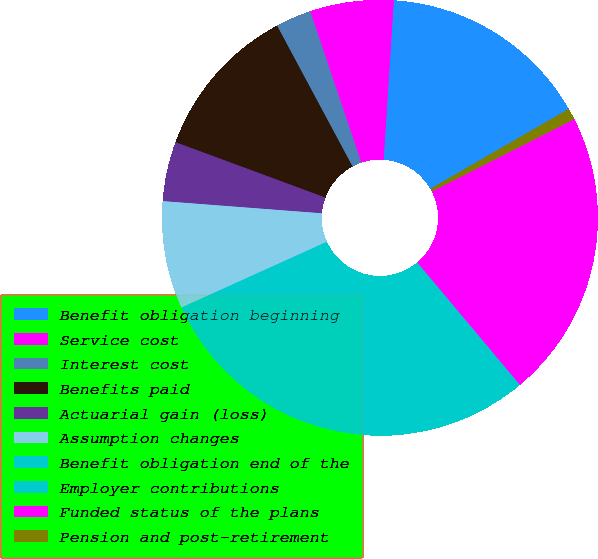Convert chart. <chart><loc_0><loc_0><loc_500><loc_500><pie_chart><fcel>Benefit obligation beginning<fcel>Service cost<fcel>Interest cost<fcel>Benefits paid<fcel>Actuarial gain (loss)<fcel>Assumption changes<fcel>Benefit obligation end of the<fcel>Employer contributions<fcel>Funded status of the plans<fcel>Pension and post-retirement<nl><fcel>15.67%<fcel>6.2%<fcel>2.64%<fcel>11.54%<fcel>4.42%<fcel>7.98%<fcel>19.59%<fcel>9.76%<fcel>21.37%<fcel>0.85%<nl></chart> 